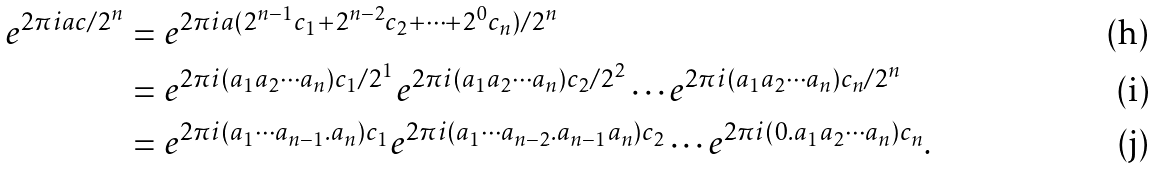Convert formula to latex. <formula><loc_0><loc_0><loc_500><loc_500>e ^ { 2 \pi i a c / 2 ^ { n } } & = e ^ { 2 \pi i a ( 2 ^ { n - 1 } c _ { 1 } + 2 ^ { n - 2 } c _ { 2 } + \cdots + 2 ^ { 0 } c _ { n } ) / 2 ^ { n } } \\ & = e ^ { 2 \pi i ( a _ { 1 } a _ { 2 } \cdots a _ { n } ) c _ { 1 } / 2 ^ { 1 } } e ^ { 2 \pi i ( a _ { 1 } a _ { 2 } \cdots a _ { n } ) c _ { 2 } / 2 ^ { 2 } } \cdots e ^ { 2 \pi i ( a _ { 1 } a _ { 2 } \cdots a _ { n } ) c _ { n } / 2 ^ { n } } \\ & = e ^ { 2 \pi i ( a _ { 1 } \cdots a _ { n - 1 } . a _ { n } ) c _ { 1 } } e ^ { 2 \pi i ( a _ { 1 } \cdots a _ { n - 2 } . a _ { n - 1 } a _ { n } ) c _ { 2 } } \cdots e ^ { 2 \pi i ( 0 . a _ { 1 } a _ { 2 } \cdots a _ { n } ) c _ { n } } .</formula> 